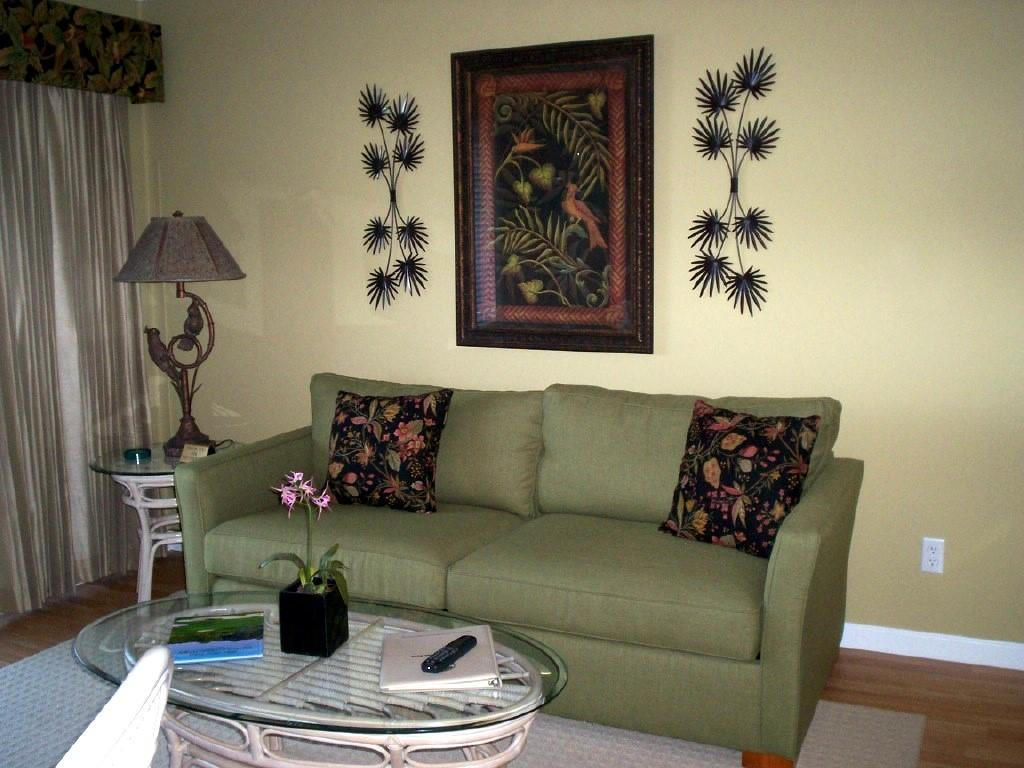What color is the wall in the image? The wall in the image is yellow. What can be seen hanging on the wall? There is a photo frame in the image. What type of lighting is present in the image? There is a lamp in the image. What type of furniture is in the image? There is a sofa in the image. What is placed on the sofa? There are pillows on the sofa. How many women are sitting on the sofa in the image? There are no women present in the image; it only shows a sofa with pillows. What type of vegetable is placed on the lamp in the image? There are no vegetables, including lettuce, present in the image. 